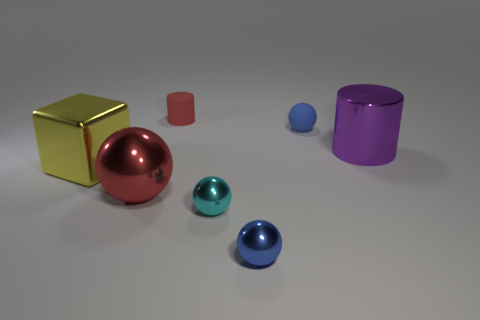Add 1 large metal cubes. How many objects exist? 8 Subtract all cylinders. How many objects are left? 5 Subtract all small cyan matte blocks. Subtract all small cylinders. How many objects are left? 6 Add 1 big cylinders. How many big cylinders are left? 2 Add 3 small blue balls. How many small blue balls exist? 5 Subtract 0 purple blocks. How many objects are left? 7 